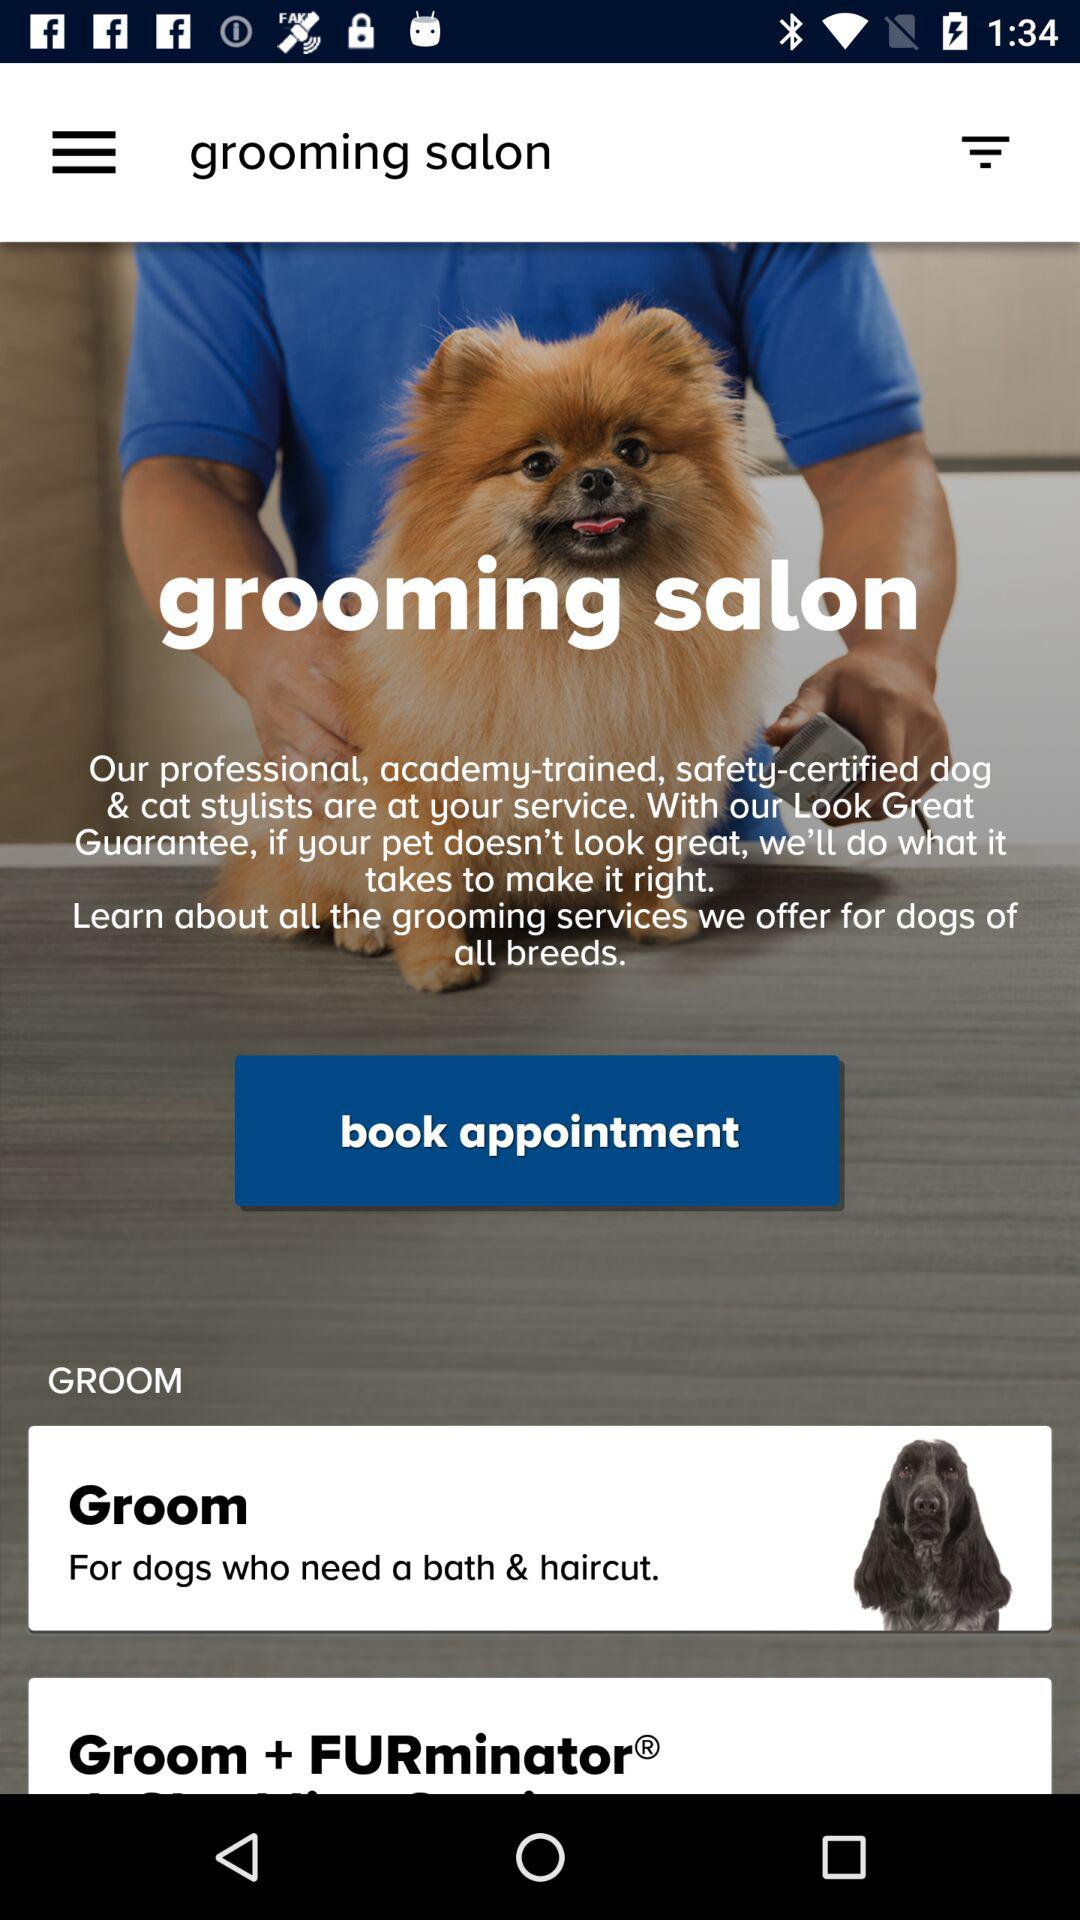How many services include a FURminator®?
Answer the question using a single word or phrase. 1 